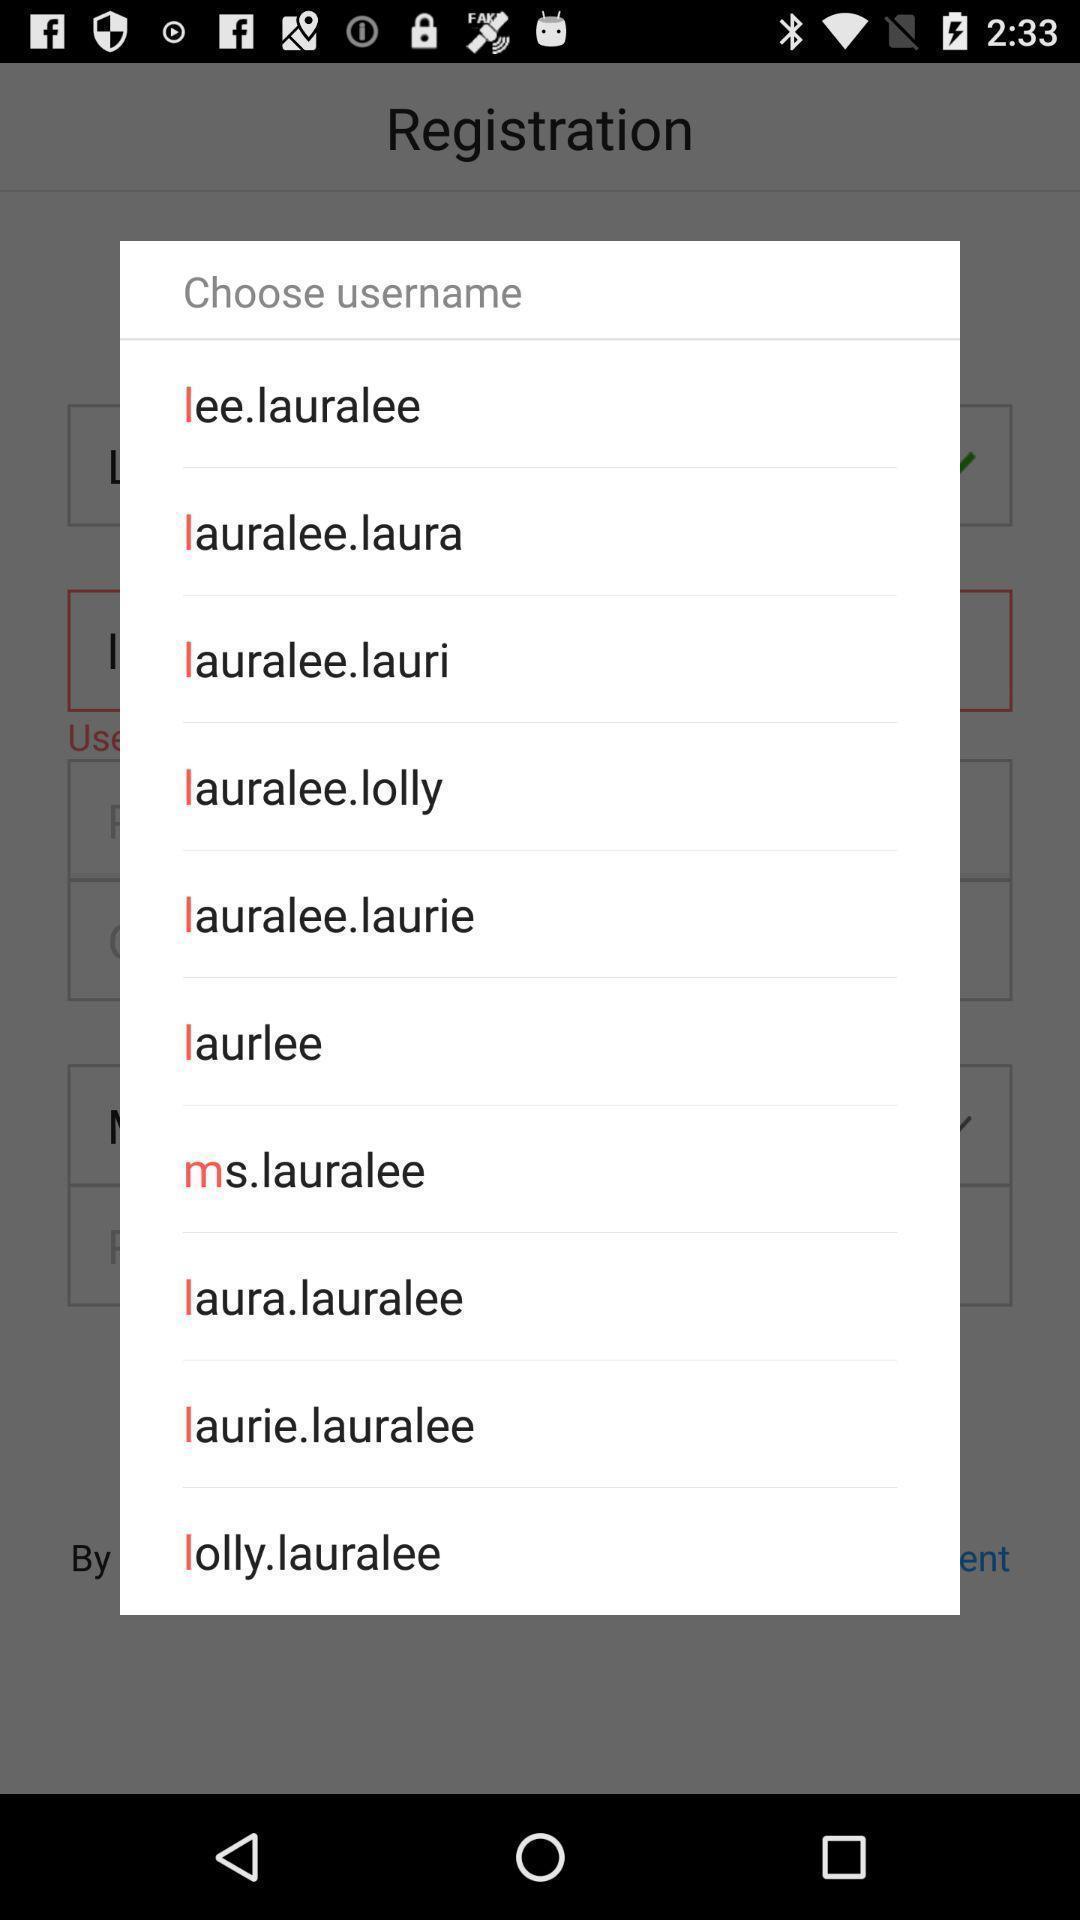Tell me about the visual elements in this screen capture. Popup of list of options. 